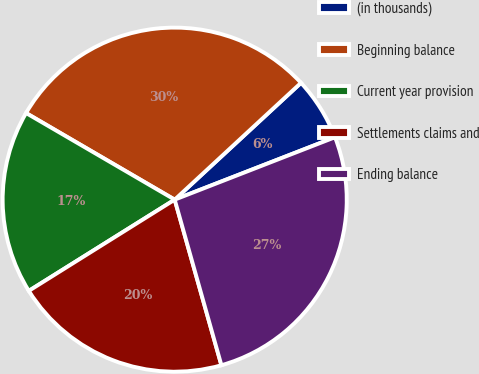<chart> <loc_0><loc_0><loc_500><loc_500><pie_chart><fcel>(in thousands)<fcel>Beginning balance<fcel>Current year provision<fcel>Settlements claims and<fcel>Ending balance<nl><fcel>5.97%<fcel>29.72%<fcel>17.29%<fcel>20.48%<fcel>26.53%<nl></chart> 